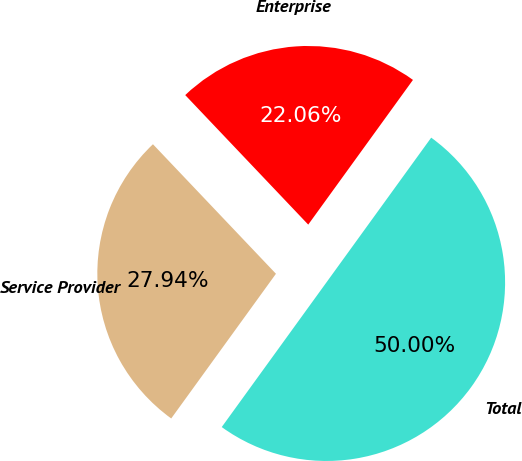<chart> <loc_0><loc_0><loc_500><loc_500><pie_chart><fcel>Service Provider<fcel>Enterprise<fcel>Total<nl><fcel>27.94%<fcel>22.06%<fcel>50.0%<nl></chart> 